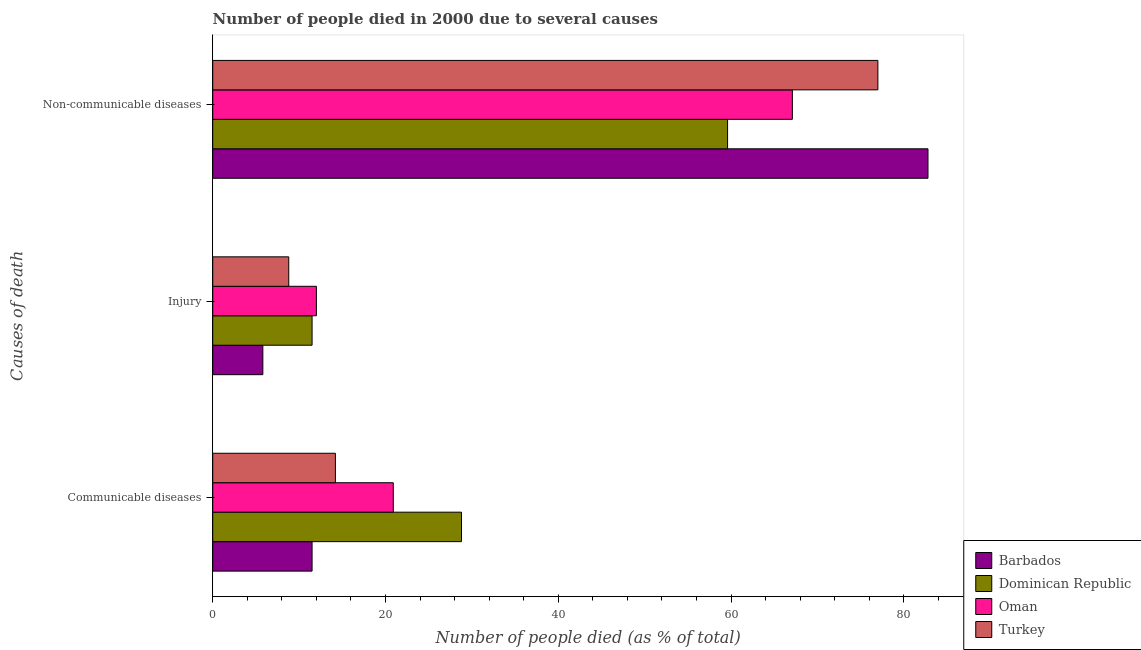How many groups of bars are there?
Give a very brief answer. 3. Are the number of bars per tick equal to the number of legend labels?
Your answer should be compact. Yes. Are the number of bars on each tick of the Y-axis equal?
Keep it short and to the point. Yes. How many bars are there on the 3rd tick from the top?
Your answer should be very brief. 4. What is the label of the 3rd group of bars from the top?
Offer a terse response. Communicable diseases. What is the number of people who dies of non-communicable diseases in Oman?
Your answer should be very brief. 67.1. Across all countries, what is the maximum number of people who dies of non-communicable diseases?
Keep it short and to the point. 82.8. Across all countries, what is the minimum number of people who died of communicable diseases?
Your answer should be compact. 11.5. In which country was the number of people who died of communicable diseases maximum?
Offer a very short reply. Dominican Republic. In which country was the number of people who dies of non-communicable diseases minimum?
Keep it short and to the point. Dominican Republic. What is the total number of people who died of injury in the graph?
Your answer should be very brief. 38.1. What is the difference between the number of people who died of injury in Barbados and that in Dominican Republic?
Provide a short and direct response. -5.7. What is the difference between the number of people who died of communicable diseases in Turkey and the number of people who dies of non-communicable diseases in Dominican Republic?
Your answer should be very brief. -45.4. What is the average number of people who dies of non-communicable diseases per country?
Your response must be concise. 71.62. What is the difference between the number of people who died of communicable diseases and number of people who dies of non-communicable diseases in Barbados?
Ensure brevity in your answer.  -71.3. In how many countries, is the number of people who dies of non-communicable diseases greater than 4 %?
Your response must be concise. 4. What is the ratio of the number of people who died of communicable diseases in Dominican Republic to that in Oman?
Offer a very short reply. 1.38. Is the number of people who died of injury in Turkey less than that in Dominican Republic?
Provide a succinct answer. Yes. What is the difference between the highest and the second highest number of people who dies of non-communicable diseases?
Keep it short and to the point. 5.8. In how many countries, is the number of people who died of communicable diseases greater than the average number of people who died of communicable diseases taken over all countries?
Your answer should be compact. 2. Is the sum of the number of people who died of communicable diseases in Turkey and Dominican Republic greater than the maximum number of people who died of injury across all countries?
Give a very brief answer. Yes. What does the 4th bar from the top in Communicable diseases represents?
Your answer should be very brief. Barbados. What does the 1st bar from the bottom in Non-communicable diseases represents?
Give a very brief answer. Barbados. How many bars are there?
Offer a very short reply. 12. How many countries are there in the graph?
Keep it short and to the point. 4. Are the values on the major ticks of X-axis written in scientific E-notation?
Provide a succinct answer. No. Does the graph contain any zero values?
Your answer should be compact. No. Does the graph contain grids?
Your answer should be very brief. No. Where does the legend appear in the graph?
Give a very brief answer. Bottom right. How many legend labels are there?
Offer a terse response. 4. What is the title of the graph?
Your answer should be very brief. Number of people died in 2000 due to several causes. What is the label or title of the X-axis?
Make the answer very short. Number of people died (as % of total). What is the label or title of the Y-axis?
Give a very brief answer. Causes of death. What is the Number of people died (as % of total) in Dominican Republic in Communicable diseases?
Offer a very short reply. 28.8. What is the Number of people died (as % of total) in Oman in Communicable diseases?
Your answer should be compact. 20.9. What is the Number of people died (as % of total) of Turkey in Communicable diseases?
Ensure brevity in your answer.  14.2. What is the Number of people died (as % of total) of Dominican Republic in Injury?
Offer a terse response. 11.5. What is the Number of people died (as % of total) of Oman in Injury?
Keep it short and to the point. 12. What is the Number of people died (as % of total) in Barbados in Non-communicable diseases?
Ensure brevity in your answer.  82.8. What is the Number of people died (as % of total) in Dominican Republic in Non-communicable diseases?
Your answer should be compact. 59.6. What is the Number of people died (as % of total) of Oman in Non-communicable diseases?
Give a very brief answer. 67.1. Across all Causes of death, what is the maximum Number of people died (as % of total) of Barbados?
Keep it short and to the point. 82.8. Across all Causes of death, what is the maximum Number of people died (as % of total) in Dominican Republic?
Ensure brevity in your answer.  59.6. Across all Causes of death, what is the maximum Number of people died (as % of total) of Oman?
Ensure brevity in your answer.  67.1. Across all Causes of death, what is the minimum Number of people died (as % of total) in Turkey?
Give a very brief answer. 8.8. What is the total Number of people died (as % of total) of Barbados in the graph?
Provide a succinct answer. 100.1. What is the total Number of people died (as % of total) in Dominican Republic in the graph?
Your answer should be very brief. 99.9. What is the difference between the Number of people died (as % of total) of Barbados in Communicable diseases and that in Injury?
Offer a terse response. 5.7. What is the difference between the Number of people died (as % of total) of Oman in Communicable diseases and that in Injury?
Your answer should be very brief. 8.9. What is the difference between the Number of people died (as % of total) in Turkey in Communicable diseases and that in Injury?
Offer a terse response. 5.4. What is the difference between the Number of people died (as % of total) in Barbados in Communicable diseases and that in Non-communicable diseases?
Your response must be concise. -71.3. What is the difference between the Number of people died (as % of total) of Dominican Republic in Communicable diseases and that in Non-communicable diseases?
Your answer should be compact. -30.8. What is the difference between the Number of people died (as % of total) in Oman in Communicable diseases and that in Non-communicable diseases?
Provide a succinct answer. -46.2. What is the difference between the Number of people died (as % of total) of Turkey in Communicable diseases and that in Non-communicable diseases?
Your answer should be very brief. -62.8. What is the difference between the Number of people died (as % of total) of Barbados in Injury and that in Non-communicable diseases?
Ensure brevity in your answer.  -77. What is the difference between the Number of people died (as % of total) of Dominican Republic in Injury and that in Non-communicable diseases?
Provide a short and direct response. -48.1. What is the difference between the Number of people died (as % of total) of Oman in Injury and that in Non-communicable diseases?
Provide a succinct answer. -55.1. What is the difference between the Number of people died (as % of total) in Turkey in Injury and that in Non-communicable diseases?
Offer a terse response. -68.2. What is the difference between the Number of people died (as % of total) of Barbados in Communicable diseases and the Number of people died (as % of total) of Oman in Injury?
Make the answer very short. -0.5. What is the difference between the Number of people died (as % of total) of Barbados in Communicable diseases and the Number of people died (as % of total) of Turkey in Injury?
Provide a short and direct response. 2.7. What is the difference between the Number of people died (as % of total) of Dominican Republic in Communicable diseases and the Number of people died (as % of total) of Oman in Injury?
Offer a very short reply. 16.8. What is the difference between the Number of people died (as % of total) of Dominican Republic in Communicable diseases and the Number of people died (as % of total) of Turkey in Injury?
Make the answer very short. 20. What is the difference between the Number of people died (as % of total) of Barbados in Communicable diseases and the Number of people died (as % of total) of Dominican Republic in Non-communicable diseases?
Offer a terse response. -48.1. What is the difference between the Number of people died (as % of total) of Barbados in Communicable diseases and the Number of people died (as % of total) of Oman in Non-communicable diseases?
Offer a terse response. -55.6. What is the difference between the Number of people died (as % of total) in Barbados in Communicable diseases and the Number of people died (as % of total) in Turkey in Non-communicable diseases?
Provide a short and direct response. -65.5. What is the difference between the Number of people died (as % of total) in Dominican Republic in Communicable diseases and the Number of people died (as % of total) in Oman in Non-communicable diseases?
Provide a succinct answer. -38.3. What is the difference between the Number of people died (as % of total) of Dominican Republic in Communicable diseases and the Number of people died (as % of total) of Turkey in Non-communicable diseases?
Your response must be concise. -48.2. What is the difference between the Number of people died (as % of total) in Oman in Communicable diseases and the Number of people died (as % of total) in Turkey in Non-communicable diseases?
Offer a terse response. -56.1. What is the difference between the Number of people died (as % of total) of Barbados in Injury and the Number of people died (as % of total) of Dominican Republic in Non-communicable diseases?
Make the answer very short. -53.8. What is the difference between the Number of people died (as % of total) of Barbados in Injury and the Number of people died (as % of total) of Oman in Non-communicable diseases?
Your response must be concise. -61.3. What is the difference between the Number of people died (as % of total) in Barbados in Injury and the Number of people died (as % of total) in Turkey in Non-communicable diseases?
Your answer should be compact. -71.2. What is the difference between the Number of people died (as % of total) of Dominican Republic in Injury and the Number of people died (as % of total) of Oman in Non-communicable diseases?
Your answer should be compact. -55.6. What is the difference between the Number of people died (as % of total) of Dominican Republic in Injury and the Number of people died (as % of total) of Turkey in Non-communicable diseases?
Ensure brevity in your answer.  -65.5. What is the difference between the Number of people died (as % of total) of Oman in Injury and the Number of people died (as % of total) of Turkey in Non-communicable diseases?
Provide a short and direct response. -65. What is the average Number of people died (as % of total) of Barbados per Causes of death?
Offer a very short reply. 33.37. What is the average Number of people died (as % of total) of Dominican Republic per Causes of death?
Offer a very short reply. 33.3. What is the average Number of people died (as % of total) in Oman per Causes of death?
Provide a succinct answer. 33.33. What is the average Number of people died (as % of total) in Turkey per Causes of death?
Offer a terse response. 33.33. What is the difference between the Number of people died (as % of total) in Barbados and Number of people died (as % of total) in Dominican Republic in Communicable diseases?
Provide a short and direct response. -17.3. What is the difference between the Number of people died (as % of total) of Barbados and Number of people died (as % of total) of Oman in Communicable diseases?
Ensure brevity in your answer.  -9.4. What is the difference between the Number of people died (as % of total) in Oman and Number of people died (as % of total) in Turkey in Communicable diseases?
Your answer should be very brief. 6.7. What is the difference between the Number of people died (as % of total) in Barbados and Number of people died (as % of total) in Oman in Injury?
Your answer should be very brief. -6.2. What is the difference between the Number of people died (as % of total) of Barbados and Number of people died (as % of total) of Turkey in Injury?
Your response must be concise. -3. What is the difference between the Number of people died (as % of total) of Dominican Republic and Number of people died (as % of total) of Oman in Injury?
Provide a short and direct response. -0.5. What is the difference between the Number of people died (as % of total) of Dominican Republic and Number of people died (as % of total) of Turkey in Injury?
Provide a short and direct response. 2.7. What is the difference between the Number of people died (as % of total) of Oman and Number of people died (as % of total) of Turkey in Injury?
Keep it short and to the point. 3.2. What is the difference between the Number of people died (as % of total) of Barbados and Number of people died (as % of total) of Dominican Republic in Non-communicable diseases?
Provide a succinct answer. 23.2. What is the difference between the Number of people died (as % of total) of Barbados and Number of people died (as % of total) of Oman in Non-communicable diseases?
Your response must be concise. 15.7. What is the difference between the Number of people died (as % of total) in Barbados and Number of people died (as % of total) in Turkey in Non-communicable diseases?
Offer a very short reply. 5.8. What is the difference between the Number of people died (as % of total) in Dominican Republic and Number of people died (as % of total) in Turkey in Non-communicable diseases?
Your answer should be compact. -17.4. What is the difference between the Number of people died (as % of total) of Oman and Number of people died (as % of total) of Turkey in Non-communicable diseases?
Your response must be concise. -9.9. What is the ratio of the Number of people died (as % of total) in Barbados in Communicable diseases to that in Injury?
Keep it short and to the point. 1.98. What is the ratio of the Number of people died (as % of total) in Dominican Republic in Communicable diseases to that in Injury?
Provide a short and direct response. 2.5. What is the ratio of the Number of people died (as % of total) in Oman in Communicable diseases to that in Injury?
Your answer should be very brief. 1.74. What is the ratio of the Number of people died (as % of total) in Turkey in Communicable diseases to that in Injury?
Provide a short and direct response. 1.61. What is the ratio of the Number of people died (as % of total) in Barbados in Communicable diseases to that in Non-communicable diseases?
Your answer should be very brief. 0.14. What is the ratio of the Number of people died (as % of total) in Dominican Republic in Communicable diseases to that in Non-communicable diseases?
Offer a terse response. 0.48. What is the ratio of the Number of people died (as % of total) in Oman in Communicable diseases to that in Non-communicable diseases?
Offer a very short reply. 0.31. What is the ratio of the Number of people died (as % of total) of Turkey in Communicable diseases to that in Non-communicable diseases?
Provide a succinct answer. 0.18. What is the ratio of the Number of people died (as % of total) of Barbados in Injury to that in Non-communicable diseases?
Make the answer very short. 0.07. What is the ratio of the Number of people died (as % of total) in Dominican Republic in Injury to that in Non-communicable diseases?
Provide a succinct answer. 0.19. What is the ratio of the Number of people died (as % of total) of Oman in Injury to that in Non-communicable diseases?
Give a very brief answer. 0.18. What is the ratio of the Number of people died (as % of total) of Turkey in Injury to that in Non-communicable diseases?
Offer a terse response. 0.11. What is the difference between the highest and the second highest Number of people died (as % of total) of Barbados?
Your response must be concise. 71.3. What is the difference between the highest and the second highest Number of people died (as % of total) of Dominican Republic?
Your answer should be compact. 30.8. What is the difference between the highest and the second highest Number of people died (as % of total) in Oman?
Ensure brevity in your answer.  46.2. What is the difference between the highest and the second highest Number of people died (as % of total) in Turkey?
Your response must be concise. 62.8. What is the difference between the highest and the lowest Number of people died (as % of total) in Barbados?
Offer a terse response. 77. What is the difference between the highest and the lowest Number of people died (as % of total) of Dominican Republic?
Give a very brief answer. 48.1. What is the difference between the highest and the lowest Number of people died (as % of total) in Oman?
Your response must be concise. 55.1. What is the difference between the highest and the lowest Number of people died (as % of total) in Turkey?
Offer a terse response. 68.2. 